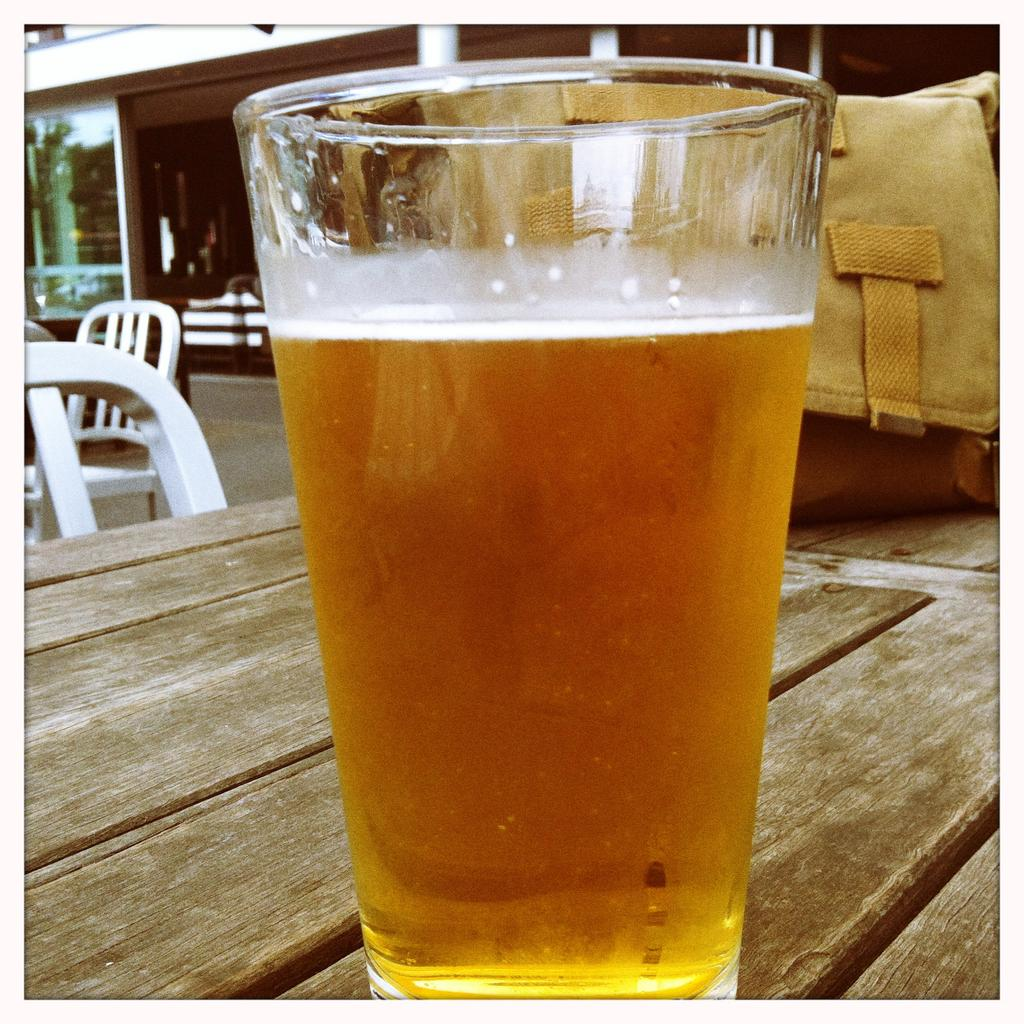What is on the table in the image? There is a glass with liquid and a bag on the table in the image. What type of furniture is present in the image? There are chairs in the image. What architectural features can be seen in the image? There are pillars visible in the image. What type of window is present in the image? There is a glass window in the image. What type of lace is used to decorate the chairs in the image? There is no lace visible on the chairs in the image. What type of education is being offered in the image? There is no indication of education or any educational setting in the image. 